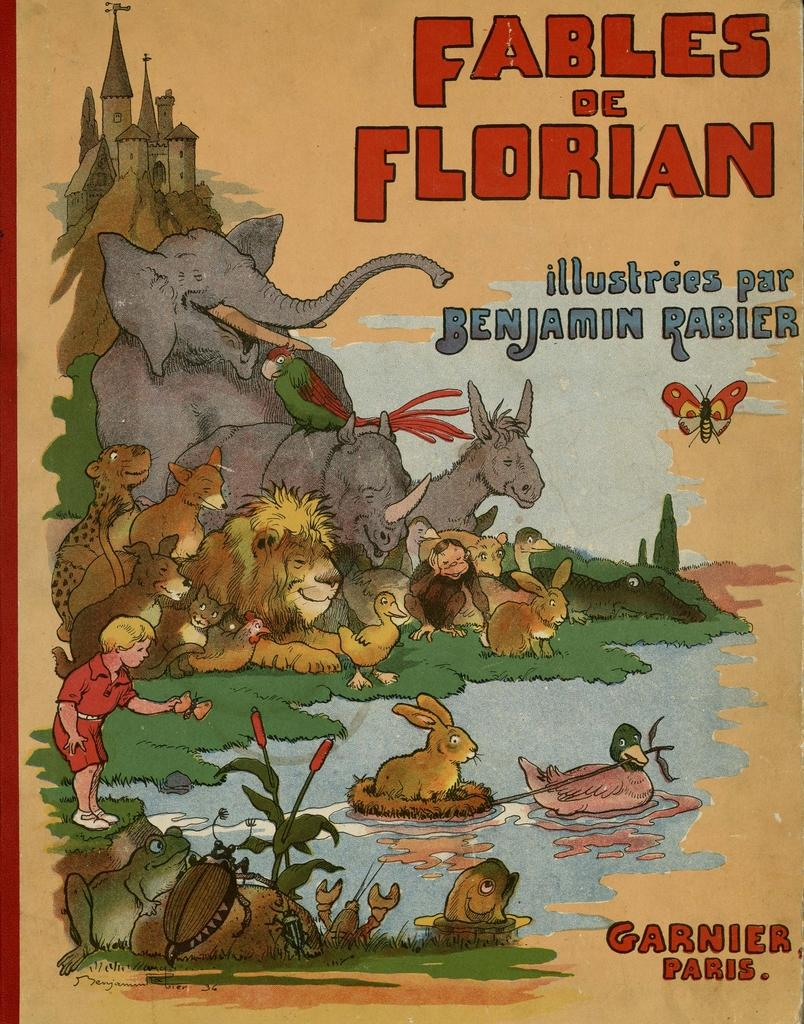What type of publication is visible in the image? There is a magazine in the image. What is depicted in the painting in the image? The painting in the image features cartoon animals. What is the connection between the painting and the magazine in the image? The name "Fables are Florian" is associated with either the painting or the magazine. Can you see any visible veins in the cartoon animals depicted in the painting? There are no visible veins in the cartoon animals, as they are not real animals and are depicted in a stylized manner. 